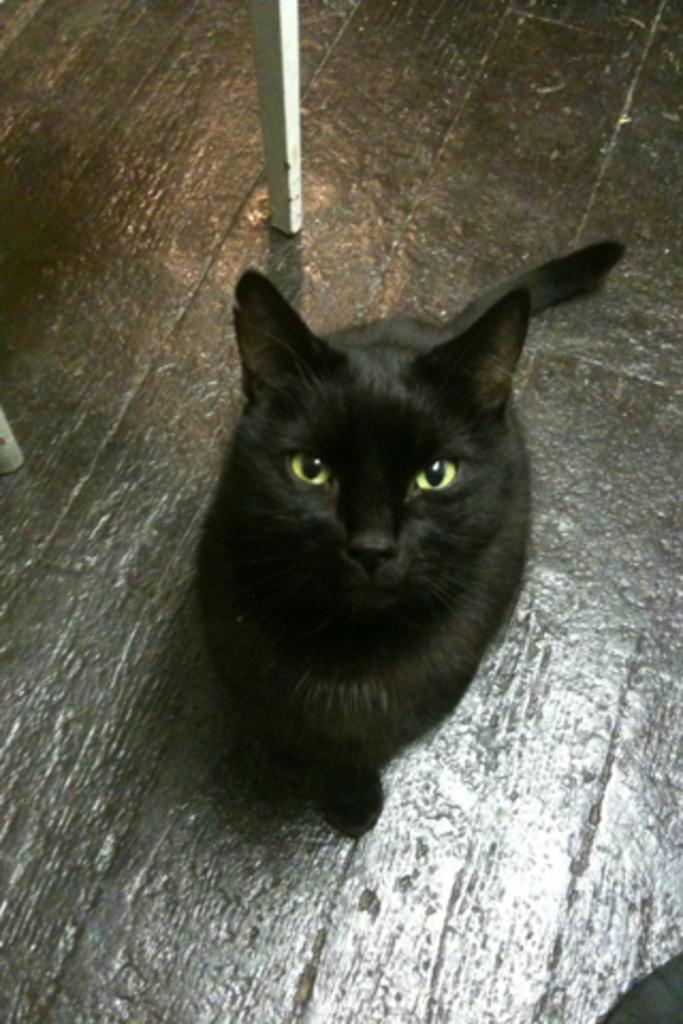What is the setting of the image? The image was likely taken indoors. What type of animal is in the image? There is a black color cat in the image. What is the cat doing in the image? The cat is sitting on the ground. What can be seen in the background of the image? There is a white color metal rod in the background of the image. What type of orange is visible in the image? There is no orange present in the image. What experience can be gained from observing the cat in the image? The image does not convey any specific experience; it simply shows a cat sitting on the ground. 